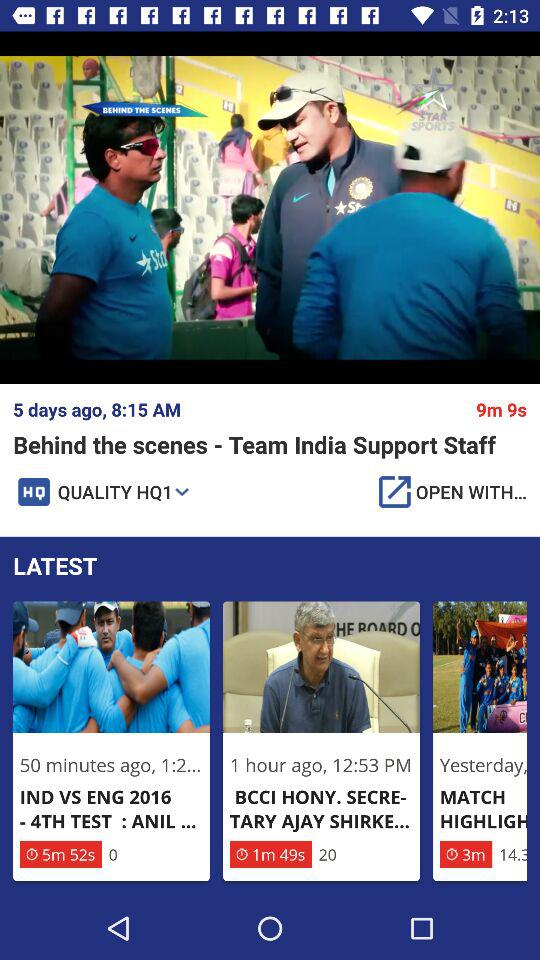What is the video length of the" Behind the scenes - Team India Support Staff? The length of the video is 9 minutes and 9 seconds. 